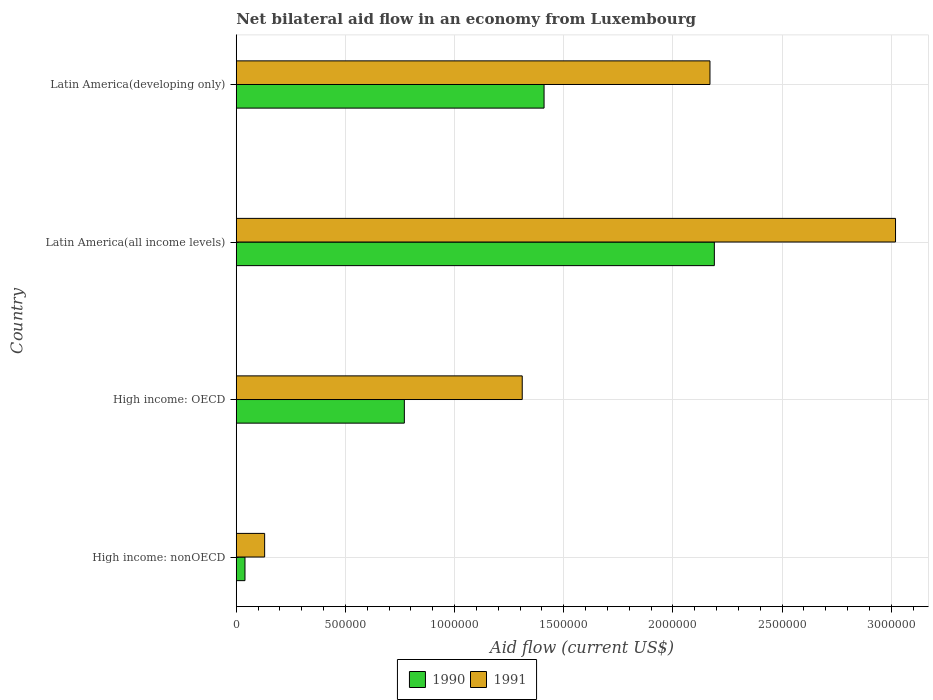Are the number of bars per tick equal to the number of legend labels?
Provide a short and direct response. Yes. Are the number of bars on each tick of the Y-axis equal?
Give a very brief answer. Yes. How many bars are there on the 4th tick from the bottom?
Provide a short and direct response. 2. What is the label of the 4th group of bars from the top?
Offer a very short reply. High income: nonOECD. In how many cases, is the number of bars for a given country not equal to the number of legend labels?
Your answer should be very brief. 0. What is the net bilateral aid flow in 1990 in High income: nonOECD?
Provide a short and direct response. 4.00e+04. Across all countries, what is the maximum net bilateral aid flow in 1990?
Give a very brief answer. 2.19e+06. Across all countries, what is the minimum net bilateral aid flow in 1991?
Offer a terse response. 1.30e+05. In which country was the net bilateral aid flow in 1991 maximum?
Your answer should be very brief. Latin America(all income levels). In which country was the net bilateral aid flow in 1990 minimum?
Make the answer very short. High income: nonOECD. What is the total net bilateral aid flow in 1990 in the graph?
Offer a very short reply. 4.41e+06. What is the difference between the net bilateral aid flow in 1991 in High income: nonOECD and that in Latin America(all income levels)?
Your response must be concise. -2.89e+06. What is the difference between the net bilateral aid flow in 1990 in High income: nonOECD and the net bilateral aid flow in 1991 in High income: OECD?
Ensure brevity in your answer.  -1.27e+06. What is the average net bilateral aid flow in 1991 per country?
Give a very brief answer. 1.66e+06. What is the difference between the net bilateral aid flow in 1991 and net bilateral aid flow in 1990 in Latin America(developing only)?
Keep it short and to the point. 7.60e+05. In how many countries, is the net bilateral aid flow in 1990 greater than 100000 US$?
Your answer should be compact. 3. What is the ratio of the net bilateral aid flow in 1990 in High income: nonOECD to that in Latin America(developing only)?
Ensure brevity in your answer.  0.03. What is the difference between the highest and the second highest net bilateral aid flow in 1991?
Keep it short and to the point. 8.50e+05. What is the difference between the highest and the lowest net bilateral aid flow in 1991?
Your answer should be very brief. 2.89e+06. How many bars are there?
Ensure brevity in your answer.  8. Are all the bars in the graph horizontal?
Offer a terse response. Yes. How many countries are there in the graph?
Ensure brevity in your answer.  4. What is the difference between two consecutive major ticks on the X-axis?
Give a very brief answer. 5.00e+05. Are the values on the major ticks of X-axis written in scientific E-notation?
Offer a terse response. No. Does the graph contain any zero values?
Provide a short and direct response. No. Where does the legend appear in the graph?
Your answer should be very brief. Bottom center. How are the legend labels stacked?
Your answer should be very brief. Horizontal. What is the title of the graph?
Give a very brief answer. Net bilateral aid flow in an economy from Luxembourg. What is the label or title of the X-axis?
Ensure brevity in your answer.  Aid flow (current US$). What is the label or title of the Y-axis?
Ensure brevity in your answer.  Country. What is the Aid flow (current US$) of 1990 in High income: nonOECD?
Ensure brevity in your answer.  4.00e+04. What is the Aid flow (current US$) in 1990 in High income: OECD?
Your answer should be compact. 7.70e+05. What is the Aid flow (current US$) of 1991 in High income: OECD?
Keep it short and to the point. 1.31e+06. What is the Aid flow (current US$) in 1990 in Latin America(all income levels)?
Your response must be concise. 2.19e+06. What is the Aid flow (current US$) of 1991 in Latin America(all income levels)?
Keep it short and to the point. 3.02e+06. What is the Aid flow (current US$) in 1990 in Latin America(developing only)?
Provide a short and direct response. 1.41e+06. What is the Aid flow (current US$) of 1991 in Latin America(developing only)?
Offer a terse response. 2.17e+06. Across all countries, what is the maximum Aid flow (current US$) of 1990?
Give a very brief answer. 2.19e+06. Across all countries, what is the maximum Aid flow (current US$) in 1991?
Provide a short and direct response. 3.02e+06. What is the total Aid flow (current US$) of 1990 in the graph?
Offer a very short reply. 4.41e+06. What is the total Aid flow (current US$) of 1991 in the graph?
Provide a short and direct response. 6.63e+06. What is the difference between the Aid flow (current US$) in 1990 in High income: nonOECD and that in High income: OECD?
Ensure brevity in your answer.  -7.30e+05. What is the difference between the Aid flow (current US$) of 1991 in High income: nonOECD and that in High income: OECD?
Provide a succinct answer. -1.18e+06. What is the difference between the Aid flow (current US$) in 1990 in High income: nonOECD and that in Latin America(all income levels)?
Your answer should be compact. -2.15e+06. What is the difference between the Aid flow (current US$) in 1991 in High income: nonOECD and that in Latin America(all income levels)?
Offer a very short reply. -2.89e+06. What is the difference between the Aid flow (current US$) in 1990 in High income: nonOECD and that in Latin America(developing only)?
Make the answer very short. -1.37e+06. What is the difference between the Aid flow (current US$) in 1991 in High income: nonOECD and that in Latin America(developing only)?
Your answer should be compact. -2.04e+06. What is the difference between the Aid flow (current US$) in 1990 in High income: OECD and that in Latin America(all income levels)?
Your response must be concise. -1.42e+06. What is the difference between the Aid flow (current US$) of 1991 in High income: OECD and that in Latin America(all income levels)?
Offer a terse response. -1.71e+06. What is the difference between the Aid flow (current US$) of 1990 in High income: OECD and that in Latin America(developing only)?
Keep it short and to the point. -6.40e+05. What is the difference between the Aid flow (current US$) of 1991 in High income: OECD and that in Latin America(developing only)?
Make the answer very short. -8.60e+05. What is the difference between the Aid flow (current US$) of 1990 in Latin America(all income levels) and that in Latin America(developing only)?
Provide a succinct answer. 7.80e+05. What is the difference between the Aid flow (current US$) in 1991 in Latin America(all income levels) and that in Latin America(developing only)?
Your answer should be compact. 8.50e+05. What is the difference between the Aid flow (current US$) in 1990 in High income: nonOECD and the Aid flow (current US$) in 1991 in High income: OECD?
Make the answer very short. -1.27e+06. What is the difference between the Aid flow (current US$) of 1990 in High income: nonOECD and the Aid flow (current US$) of 1991 in Latin America(all income levels)?
Offer a very short reply. -2.98e+06. What is the difference between the Aid flow (current US$) of 1990 in High income: nonOECD and the Aid flow (current US$) of 1991 in Latin America(developing only)?
Give a very brief answer. -2.13e+06. What is the difference between the Aid flow (current US$) in 1990 in High income: OECD and the Aid flow (current US$) in 1991 in Latin America(all income levels)?
Give a very brief answer. -2.25e+06. What is the difference between the Aid flow (current US$) in 1990 in High income: OECD and the Aid flow (current US$) in 1991 in Latin America(developing only)?
Ensure brevity in your answer.  -1.40e+06. What is the average Aid flow (current US$) of 1990 per country?
Your response must be concise. 1.10e+06. What is the average Aid flow (current US$) in 1991 per country?
Make the answer very short. 1.66e+06. What is the difference between the Aid flow (current US$) of 1990 and Aid flow (current US$) of 1991 in High income: nonOECD?
Give a very brief answer. -9.00e+04. What is the difference between the Aid flow (current US$) of 1990 and Aid flow (current US$) of 1991 in High income: OECD?
Offer a very short reply. -5.40e+05. What is the difference between the Aid flow (current US$) in 1990 and Aid flow (current US$) in 1991 in Latin America(all income levels)?
Your response must be concise. -8.30e+05. What is the difference between the Aid flow (current US$) of 1990 and Aid flow (current US$) of 1991 in Latin America(developing only)?
Your answer should be compact. -7.60e+05. What is the ratio of the Aid flow (current US$) of 1990 in High income: nonOECD to that in High income: OECD?
Provide a succinct answer. 0.05. What is the ratio of the Aid flow (current US$) of 1991 in High income: nonOECD to that in High income: OECD?
Your answer should be very brief. 0.1. What is the ratio of the Aid flow (current US$) of 1990 in High income: nonOECD to that in Latin America(all income levels)?
Keep it short and to the point. 0.02. What is the ratio of the Aid flow (current US$) of 1991 in High income: nonOECD to that in Latin America(all income levels)?
Provide a succinct answer. 0.04. What is the ratio of the Aid flow (current US$) in 1990 in High income: nonOECD to that in Latin America(developing only)?
Your answer should be very brief. 0.03. What is the ratio of the Aid flow (current US$) of 1991 in High income: nonOECD to that in Latin America(developing only)?
Offer a very short reply. 0.06. What is the ratio of the Aid flow (current US$) in 1990 in High income: OECD to that in Latin America(all income levels)?
Offer a very short reply. 0.35. What is the ratio of the Aid flow (current US$) in 1991 in High income: OECD to that in Latin America(all income levels)?
Your answer should be very brief. 0.43. What is the ratio of the Aid flow (current US$) of 1990 in High income: OECD to that in Latin America(developing only)?
Offer a terse response. 0.55. What is the ratio of the Aid flow (current US$) in 1991 in High income: OECD to that in Latin America(developing only)?
Your answer should be compact. 0.6. What is the ratio of the Aid flow (current US$) in 1990 in Latin America(all income levels) to that in Latin America(developing only)?
Your response must be concise. 1.55. What is the ratio of the Aid flow (current US$) in 1991 in Latin America(all income levels) to that in Latin America(developing only)?
Your answer should be compact. 1.39. What is the difference between the highest and the second highest Aid flow (current US$) in 1990?
Offer a very short reply. 7.80e+05. What is the difference between the highest and the second highest Aid flow (current US$) of 1991?
Your answer should be very brief. 8.50e+05. What is the difference between the highest and the lowest Aid flow (current US$) of 1990?
Give a very brief answer. 2.15e+06. What is the difference between the highest and the lowest Aid flow (current US$) of 1991?
Your response must be concise. 2.89e+06. 